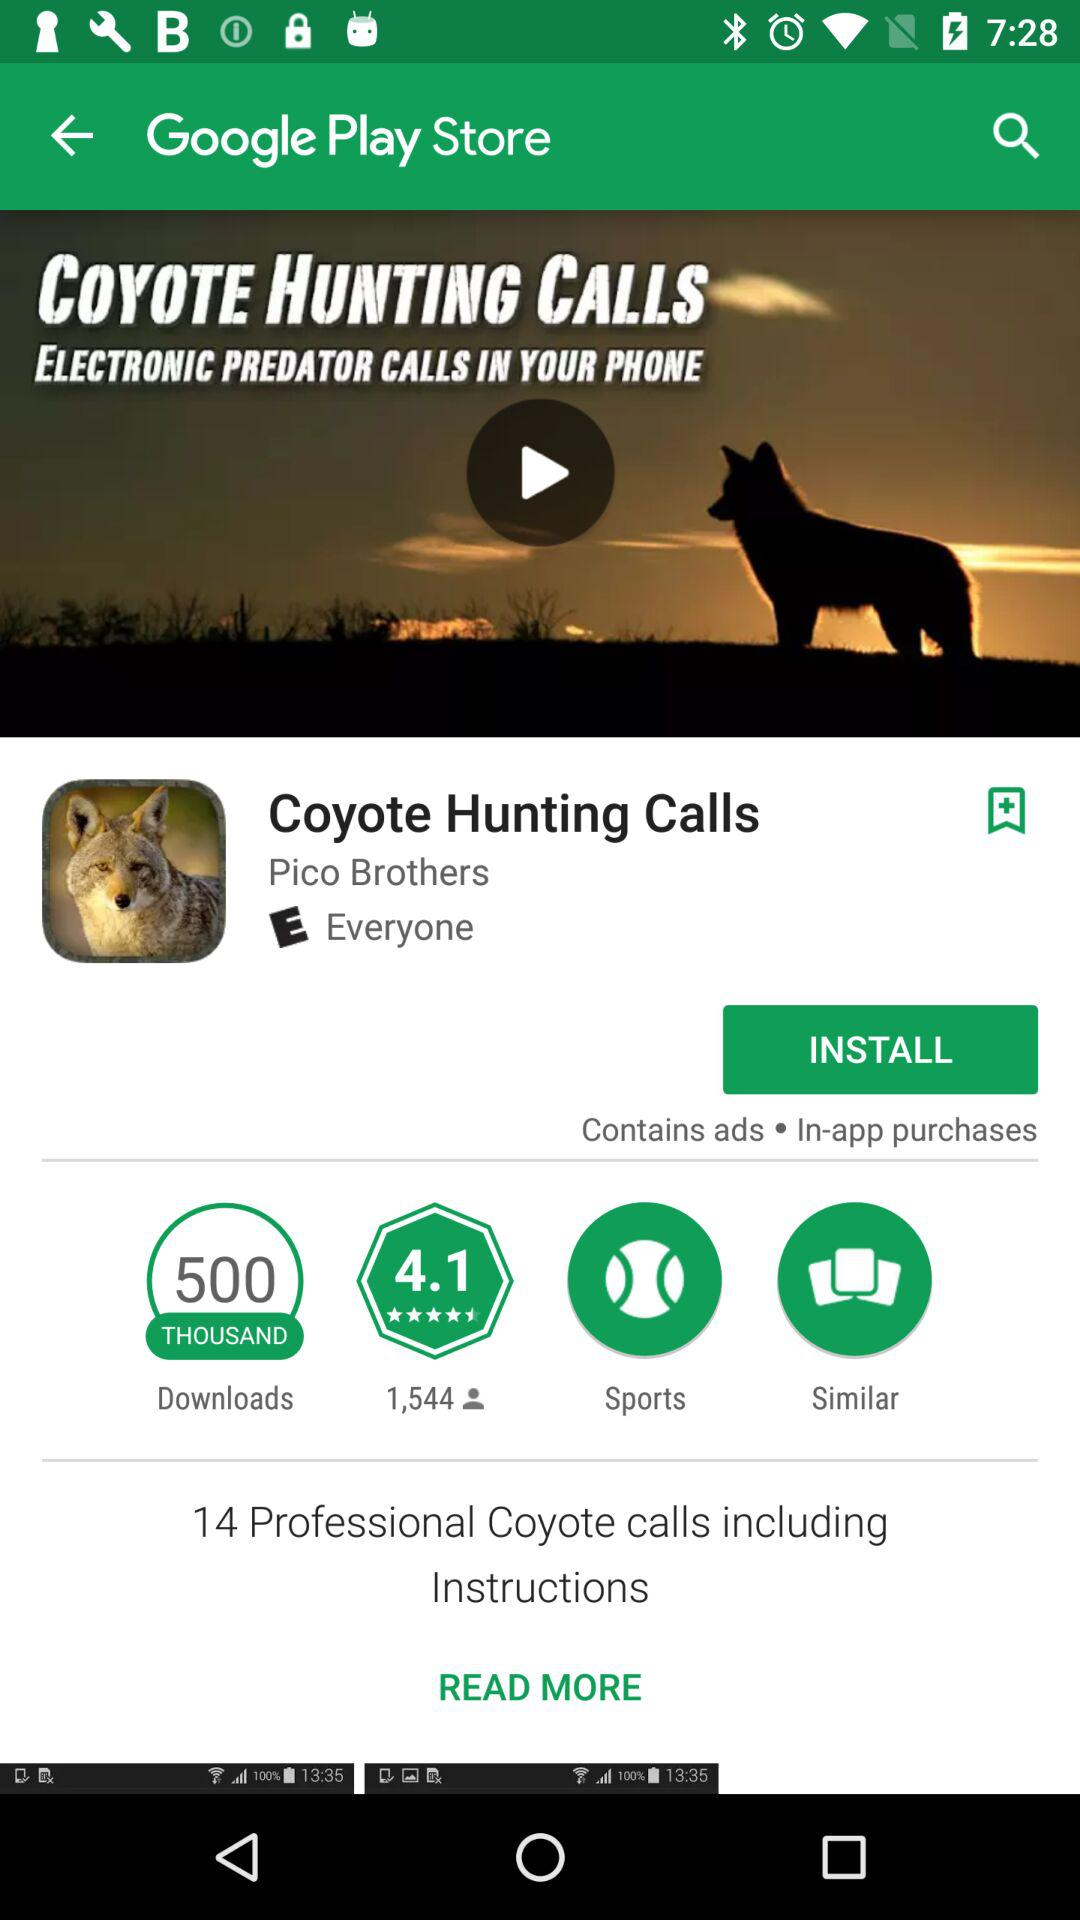What is the application name? The application names are "Coyote Hunting Calls" and "Google Play Store". 